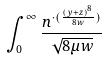Convert formula to latex. <formula><loc_0><loc_0><loc_500><loc_500>\int _ { 0 } ^ { \infty } \frac { n ^ { \cdot ( \frac { ( y + z ) ^ { 8 } } { 8 w } ) } } { \sqrt { 8 \mu w } }</formula> 